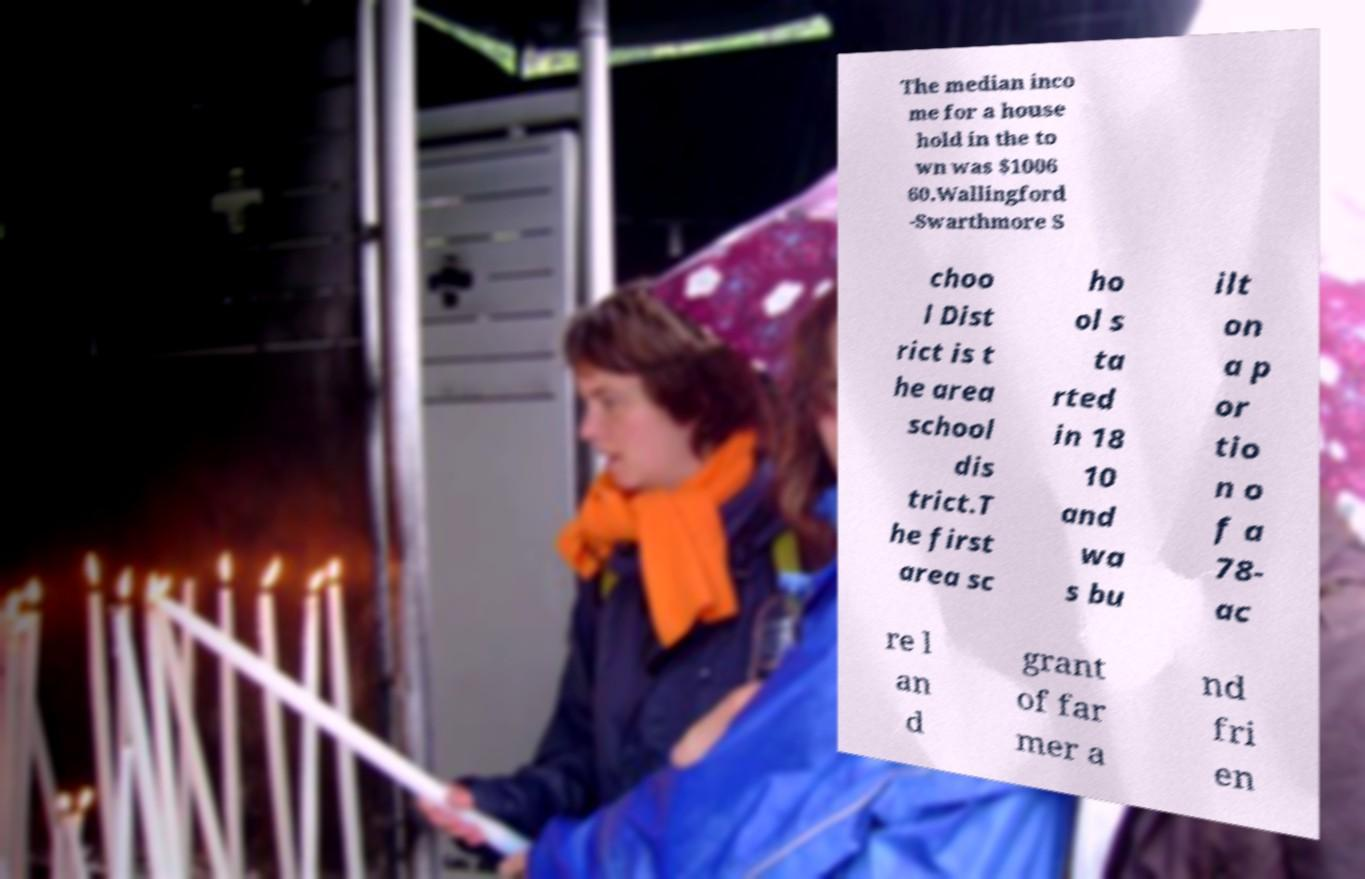For documentation purposes, I need the text within this image transcribed. Could you provide that? The median inco me for a house hold in the to wn was $1006 60.Wallingford -Swarthmore S choo l Dist rict is t he area school dis trict.T he first area sc ho ol s ta rted in 18 10 and wa s bu ilt on a p or tio n o f a 78- ac re l an d grant of far mer a nd fri en 